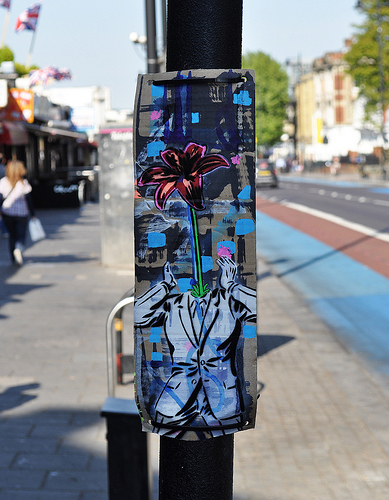<image>
Is the pole on the ground? Yes. Looking at the image, I can see the pole is positioned on top of the ground, with the ground providing support. 